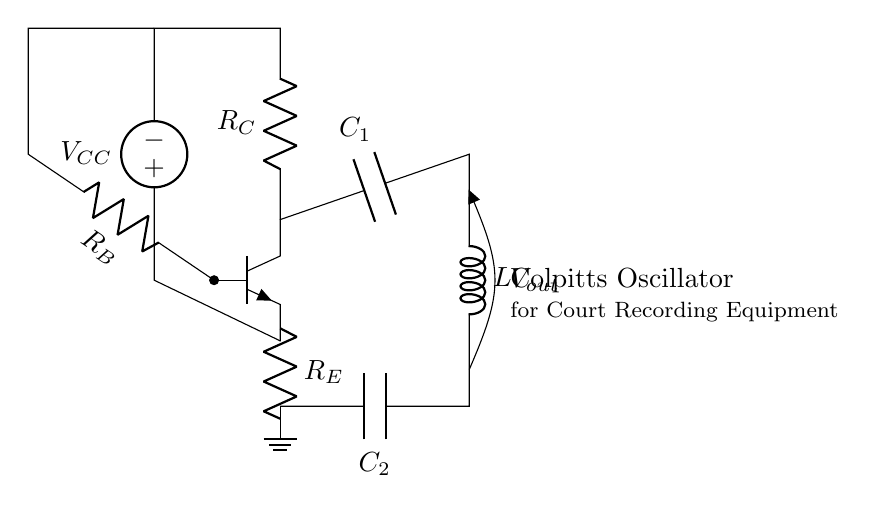What type of transistor is used in this circuit? The circuit diagram shows an NPN transistor, which is indicated by the npn label next to the device symbol.
Answer: NPN What components make up the tank circuit in this Colpitts oscillator? The tank circuit consists of two capacitors (C1 and C2) and one inductor (L), as shown in the lower part of the circuit diagram.
Answer: C1, C2, L What is the purpose of R_E in this oscillator? R_E, or the emitter resistor, is used to provide stability and improve linearity in the transistor operation, which is crucial for generating stable oscillations.
Answer: Stability What does V_out represent in this circuit? V_out is the output voltage signal produced by the Colpitts oscillator, typically taken across the tank circuit, as denoted in the diagram.
Answer: Output voltage How does the Colpitts oscillator generate frequency? The frequency is determined by the values of the capacitors C1, C2, and the inductor L, using the formula for frequency of oscillation, which involves these components in a feedback arrangement.
Answer: Component values What is the role of R_B in the circuit? R_B is the biasing resistor connected to the base of the transistor, and it controls the base current, which is essential for operating the transistor in the active region.
Answer: Biasing current What type of oscillator is represented by this circuit? This circuit specifically represents a Colpitts oscillator, which is identified by the unique configuration of the tank circuit and feedback mechanism.
Answer: Colpitts oscillator 